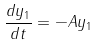<formula> <loc_0><loc_0><loc_500><loc_500>\frac { d y _ { 1 } } { d t } = - A y _ { 1 }</formula> 